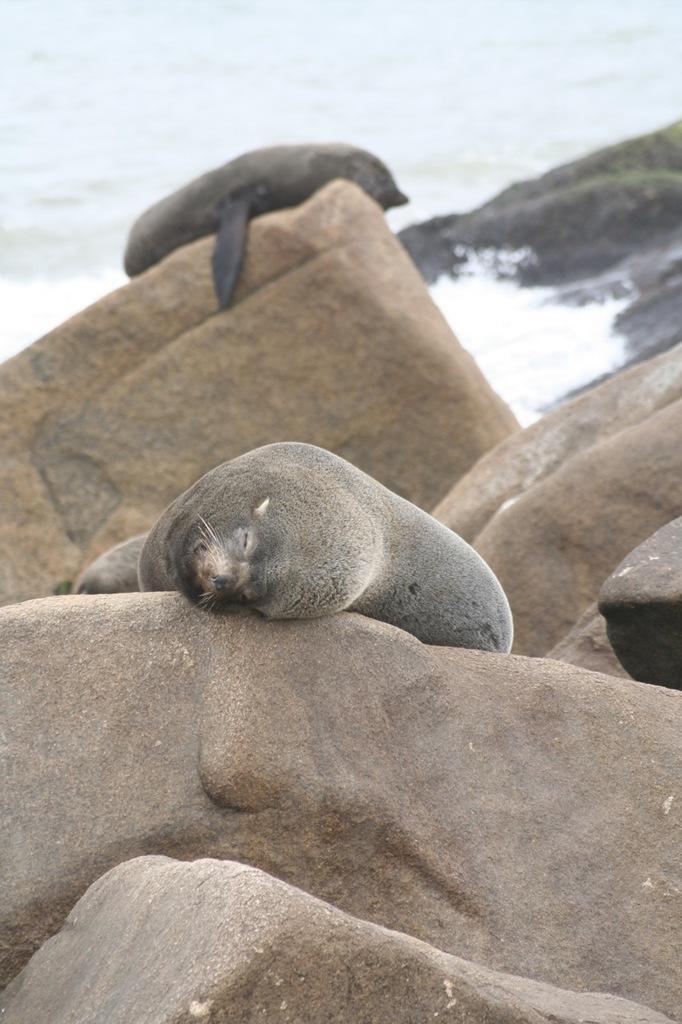How would you summarize this image in a sentence or two? In this picture I can observe two seals laying on the large stones. The seals are in grey color. In the background there is an ocean. 